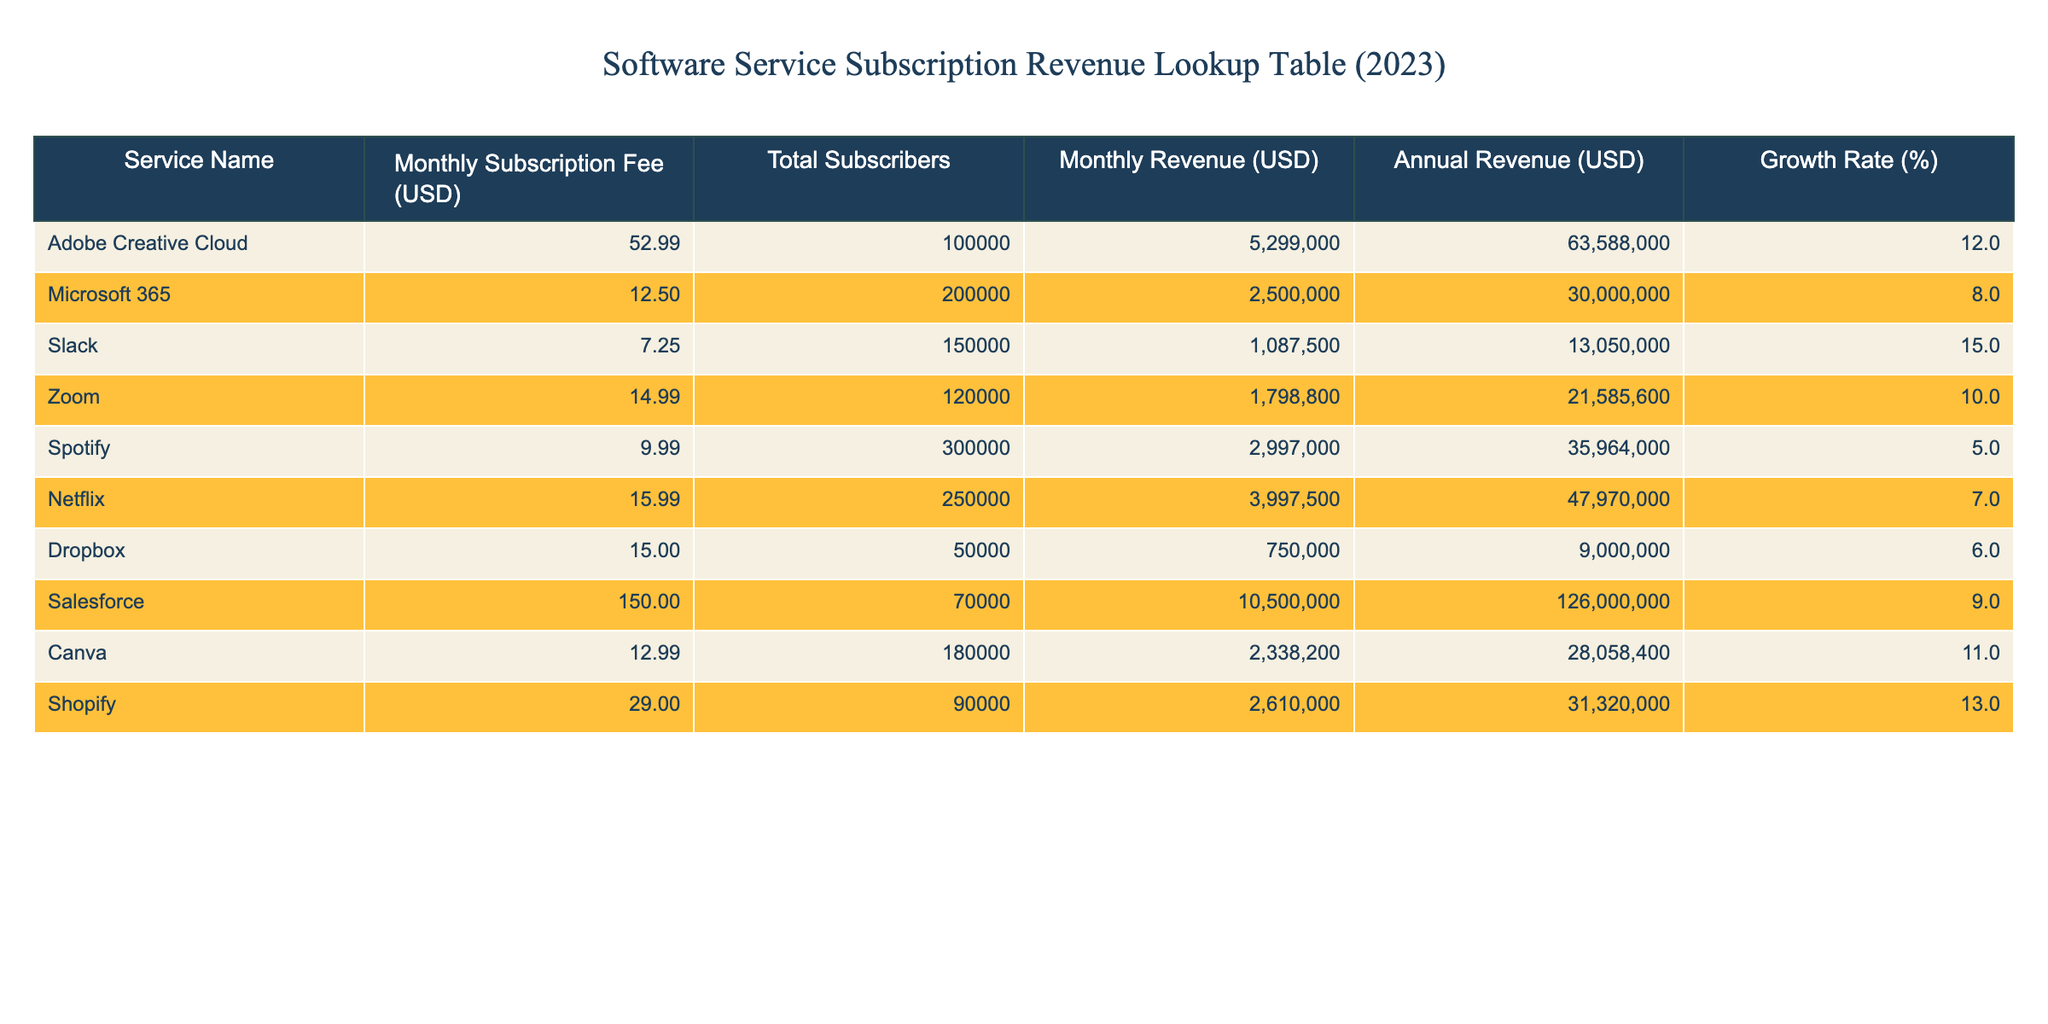What is the monthly subscription fee for Adobe Creative Cloud? The table lists Adobe Creative Cloud with a monthly subscription fee in the second column. Referring to the table, the fee for Adobe Creative Cloud is 52.99 USD.
Answer: 52.99 USD How many total subscribers does Slack have? Looking at the third column of the table, Slack has a total subscriber count listed as 150,000.
Answer: 150,000 Which service has the highest monthly revenue? By reviewing the monthly revenue figures in the fourth column, Salesforce shows 10,500,000 USD as its monthly revenue, which is greater than the other services listed.
Answer: Salesforce What is the total annual revenue for Spotify? The annual revenue can be found in the fifth column next to Spotify. The table indicates that Spotify has an annual revenue of 35,964,000 USD.
Answer: 35,964,000 USD Is the growth rate for Dropbox greater than 8%? By checking the growth rate in the last column for Dropbox, it shows a value of 6%, which is less than 8%. Therefore, the statement is false.
Answer: No What is the average monthly subscription fee of all services listed? To find the average, add all monthly fees from the second column: (52.99 + 12.50 + 7.25 + 14.99 + 9.99 + 15.99 + 15.00 + 150.00 + 12.99 + 29.00) = 307.70. Divide by the total number of services (10) gives 30.77.
Answer: 30.77 USD How many services have a monthly revenue greater than 2,500,000 USD? Reviewing the monthly revenue column, count instances above 2,500,000 USD. The services that qualify are Adobe Creative Cloud, Microsoft 365, Slack, Zoom, Netflix, Salesforce, and Shopify. That totals to 7 services.
Answer: 7 What is the total subscriber count for services with a growth rate above 10%? First, identify services with a growth rate greater than 10%, which are Adobe Creative Cloud (100,000), Slack (150,000), and Shopify (90,000). Then sum their subscribers: 100,000 + 150,000 + 90,000 = 340,000 subscribers.
Answer: 340,000 Is the monthly subscription fee for Canva higher than that of Spotify? The monthly fee for Canva is 12.99 USD, whereas for Spotify it is 9.99 USD. Since 12.99 is greater than 9.99, the answer is yes.
Answer: Yes 